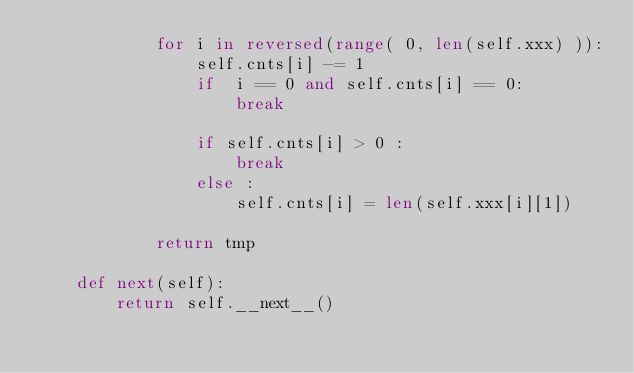Convert code to text. <code><loc_0><loc_0><loc_500><loc_500><_Python_>            for i in reversed(range( 0, len(self.xxx) )):
                self.cnts[i] -= 1
                if  i == 0 and self.cnts[i] == 0:
                    break

                if self.cnts[i] > 0 :
                    break
                else :
                    self.cnts[i] = len(self.xxx[i][1])

            return tmp

    def next(self):
        return self.__next__()

</code> 